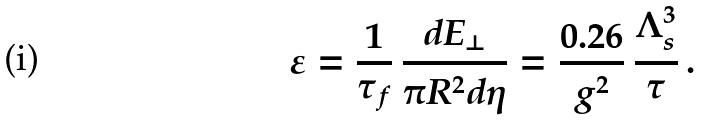<formula> <loc_0><loc_0><loc_500><loc_500>\varepsilon = \frac { 1 } { \tau _ { f } } \, \frac { d E _ { \perp } } { \pi R ^ { 2 } d \eta } = \frac { 0 . 2 6 } { g ^ { 2 } } \, \frac { \Lambda _ { s } ^ { 3 } } { \tau } \, .</formula> 